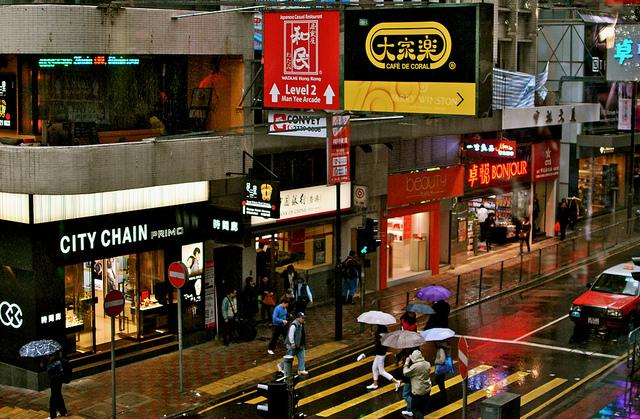Is the traffic halted?
Keep it brief. Yes. What language is posted here?
Short answer required. Chinese. What is the weather like?
Write a very short answer. Rainy. 